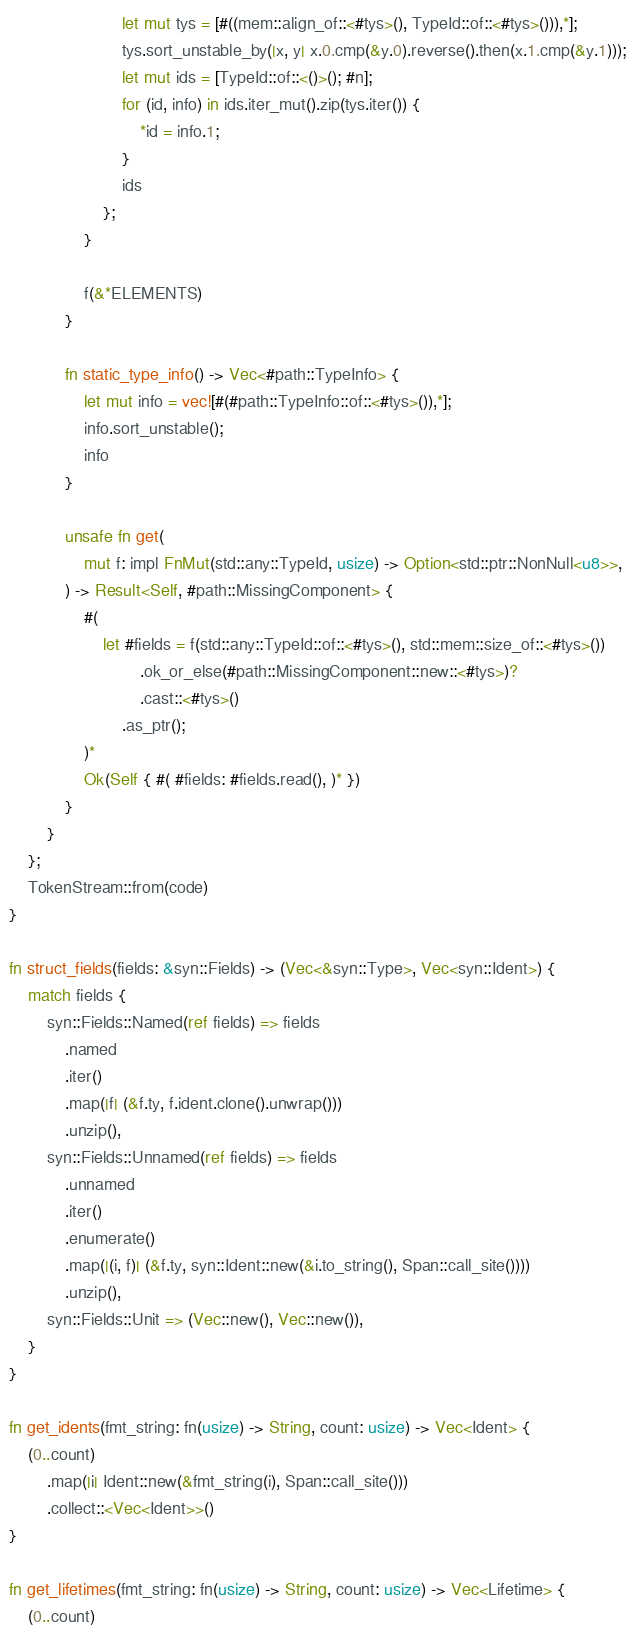Convert code to text. <code><loc_0><loc_0><loc_500><loc_500><_Rust_>
                        let mut tys = [#((mem::align_of::<#tys>(), TypeId::of::<#tys>())),*];
                        tys.sort_unstable_by(|x, y| x.0.cmp(&y.0).reverse().then(x.1.cmp(&y.1)));
                        let mut ids = [TypeId::of::<()>(); #n];
                        for (id, info) in ids.iter_mut().zip(tys.iter()) {
                            *id = info.1;
                        }
                        ids
                    };
                }

                f(&*ELEMENTS)
            }

            fn static_type_info() -> Vec<#path::TypeInfo> {
                let mut info = vec![#(#path::TypeInfo::of::<#tys>()),*];
                info.sort_unstable();
                info
            }

            unsafe fn get(
                mut f: impl FnMut(std::any::TypeId, usize) -> Option<std::ptr::NonNull<u8>>,
            ) -> Result<Self, #path::MissingComponent> {
                #(
                    let #fields = f(std::any::TypeId::of::<#tys>(), std::mem::size_of::<#tys>())
                            .ok_or_else(#path::MissingComponent::new::<#tys>)?
                            .cast::<#tys>()
                        .as_ptr();
                )*
                Ok(Self { #( #fields: #fields.read(), )* })
            }
        }
    };
    TokenStream::from(code)
}

fn struct_fields(fields: &syn::Fields) -> (Vec<&syn::Type>, Vec<syn::Ident>) {
    match fields {
        syn::Fields::Named(ref fields) => fields
            .named
            .iter()
            .map(|f| (&f.ty, f.ident.clone().unwrap()))
            .unzip(),
        syn::Fields::Unnamed(ref fields) => fields
            .unnamed
            .iter()
            .enumerate()
            .map(|(i, f)| (&f.ty, syn::Ident::new(&i.to_string(), Span::call_site())))
            .unzip(),
        syn::Fields::Unit => (Vec::new(), Vec::new()),
    }
}

fn get_idents(fmt_string: fn(usize) -> String, count: usize) -> Vec<Ident> {
    (0..count)
        .map(|i| Ident::new(&fmt_string(i), Span::call_site()))
        .collect::<Vec<Ident>>()
}

fn get_lifetimes(fmt_string: fn(usize) -> String, count: usize) -> Vec<Lifetime> {
    (0..count)</code> 